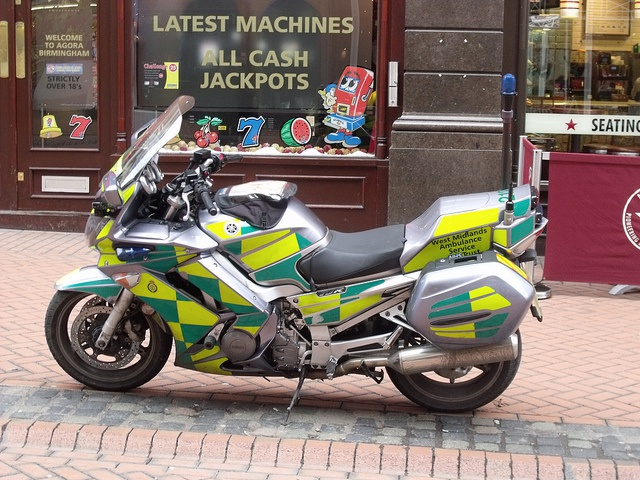Describe the objects in this image and their specific colors. I can see a motorcycle in maroon, black, gray, lightgray, and darkgray tones in this image. 